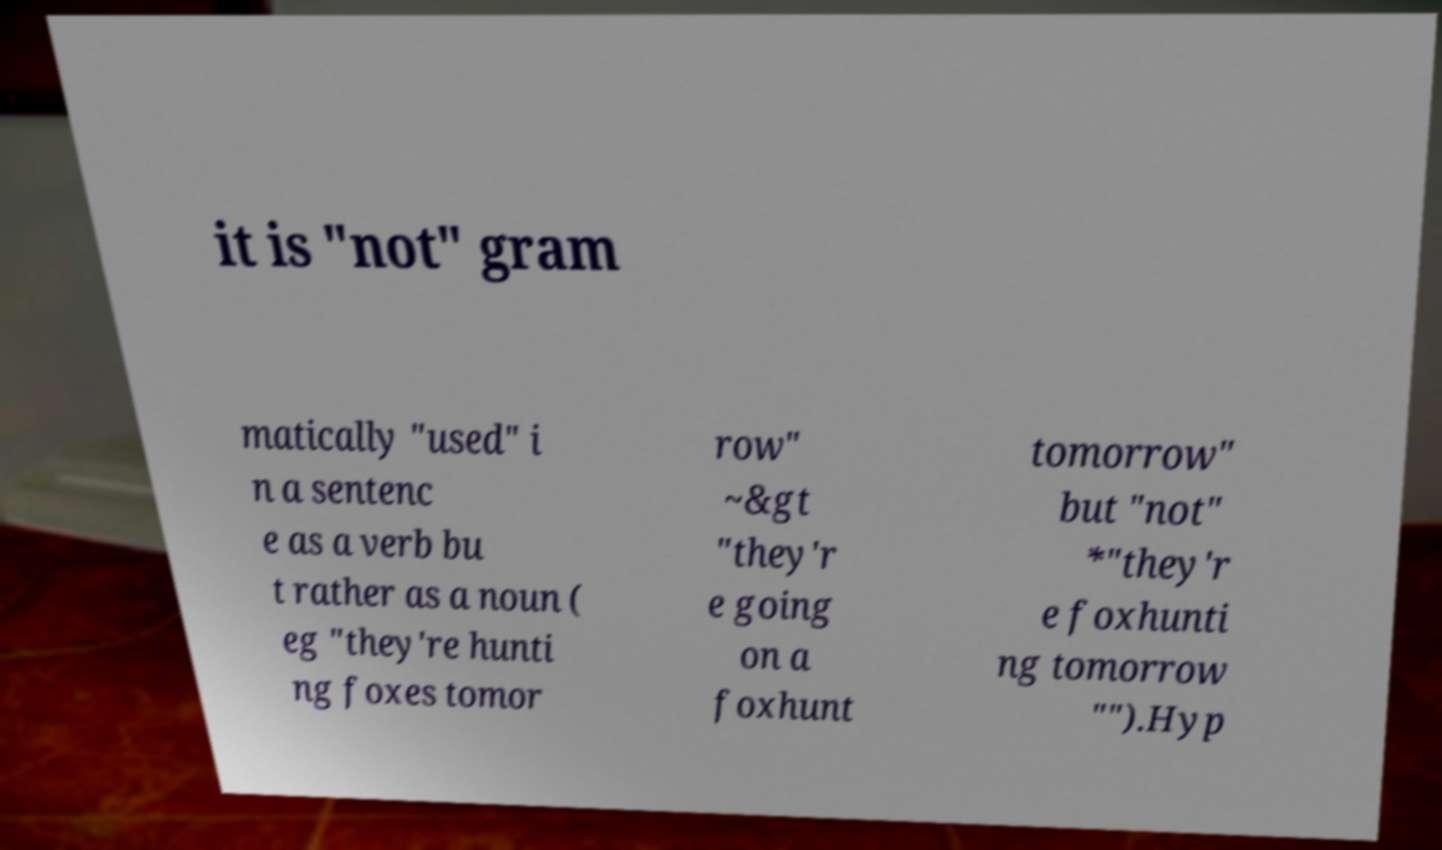Please identify and transcribe the text found in this image. it is "not" gram matically "used" i n a sentenc e as a verb bu t rather as a noun ( eg "they're hunti ng foxes tomor row" ~&gt "they'r e going on a foxhunt tomorrow" but "not" *"they'r e foxhunti ng tomorrow "").Hyp 